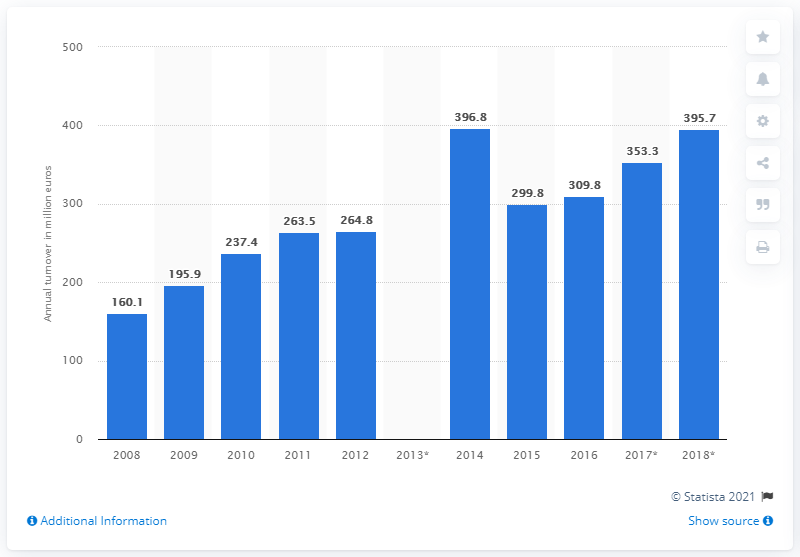Mention a couple of crucial points in this snapshot. The processing and preserving of fish, crustaceans, and mollusks industry had a turnover of 395.7 million in 2018. 